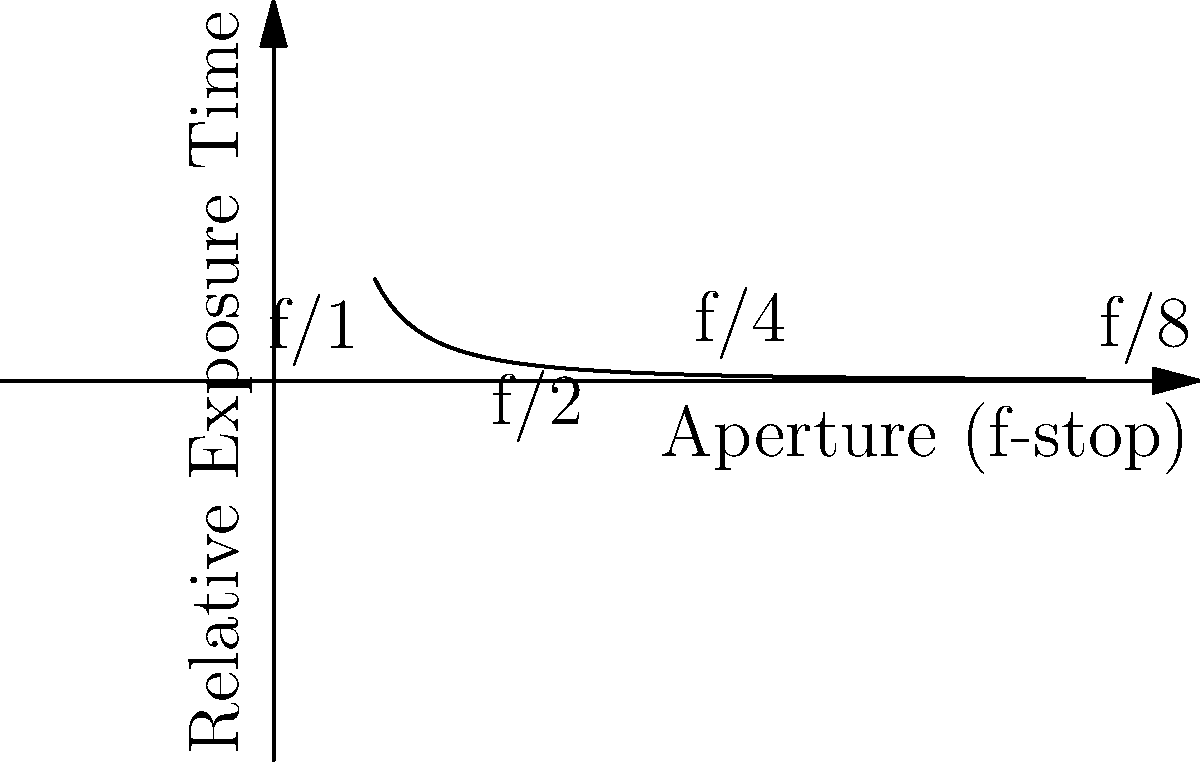As a photographer capturing the vibrant street scenes of Hong Kong, you're experimenting with different aperture settings. The graph shows the relationship between aperture (f-stop) and relative exposure time. If the correct exposure time at f/2 is 1/125 seconds, what would be the correct exposure time at f/8 to maintain the same exposure, assuming constant light intensity and ISO? Let's approach this step-by-step:

1) The graph shows that the exposure time is inversely proportional to the square of the f-stop number. This relationship can be expressed as:

   $$ \text{Exposure Time} \propto \frac{1}{(\text{f-stop})^2} $$

2) We need to find the ratio of exposure times between f/2 and f/8:

   $$ \frac{\text{Time at f/8}}{\text{Time at f/2}} = \frac{(2)^2}{(8)^2} = \frac{4}{64} = \frac{1}{16} $$

3) This means the exposure time at f/8 will be 1/16 of the time at f/2.

4) Given that the exposure time at f/2 is 1/125 seconds, we can calculate the time at f/8:

   $$ \text{Time at f/8} = \frac{1}{125} \times \frac{1}{16} = \frac{1}{2000} \text{ seconds} $$

Therefore, to maintain the same exposure at f/8 as at f/2, the shutter speed needs to be set to 1/2000 seconds.
Answer: 1/2000 seconds 